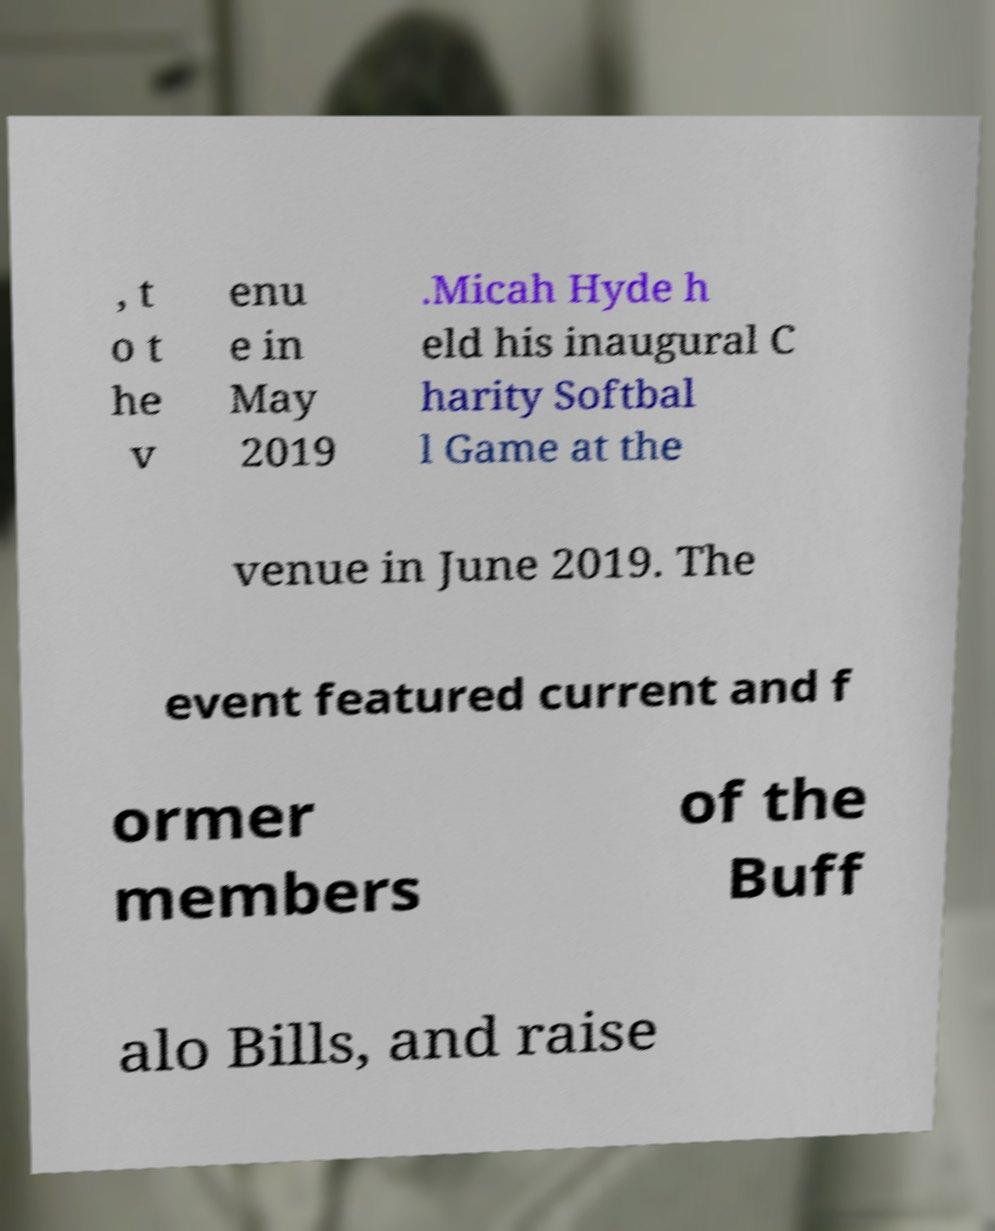Could you assist in decoding the text presented in this image and type it out clearly? , t o t he v enu e in May 2019 .Micah Hyde h eld his inaugural C harity Softbal l Game at the venue in June 2019. The event featured current and f ormer members of the Buff alo Bills, and raise 